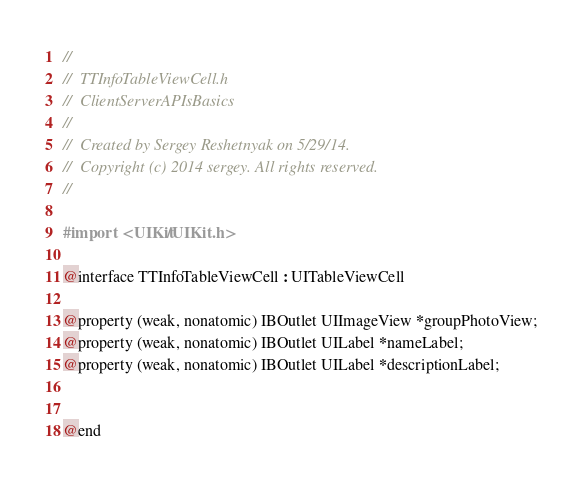<code> <loc_0><loc_0><loc_500><loc_500><_C_>//
//  TTInfoTableViewCell.h
//  ClientServerAPIsBasics
//
//  Created by Sergey Reshetnyak on 5/29/14.
//  Copyright (c) 2014 sergey. All rights reserved.
//

#import <UIKit/UIKit.h>

@interface TTInfoTableViewCell : UITableViewCell

@property (weak, nonatomic) IBOutlet UIImageView *groupPhotoView;
@property (weak, nonatomic) IBOutlet UILabel *nameLabel;
@property (weak, nonatomic) IBOutlet UILabel *descriptionLabel;


@end
</code> 